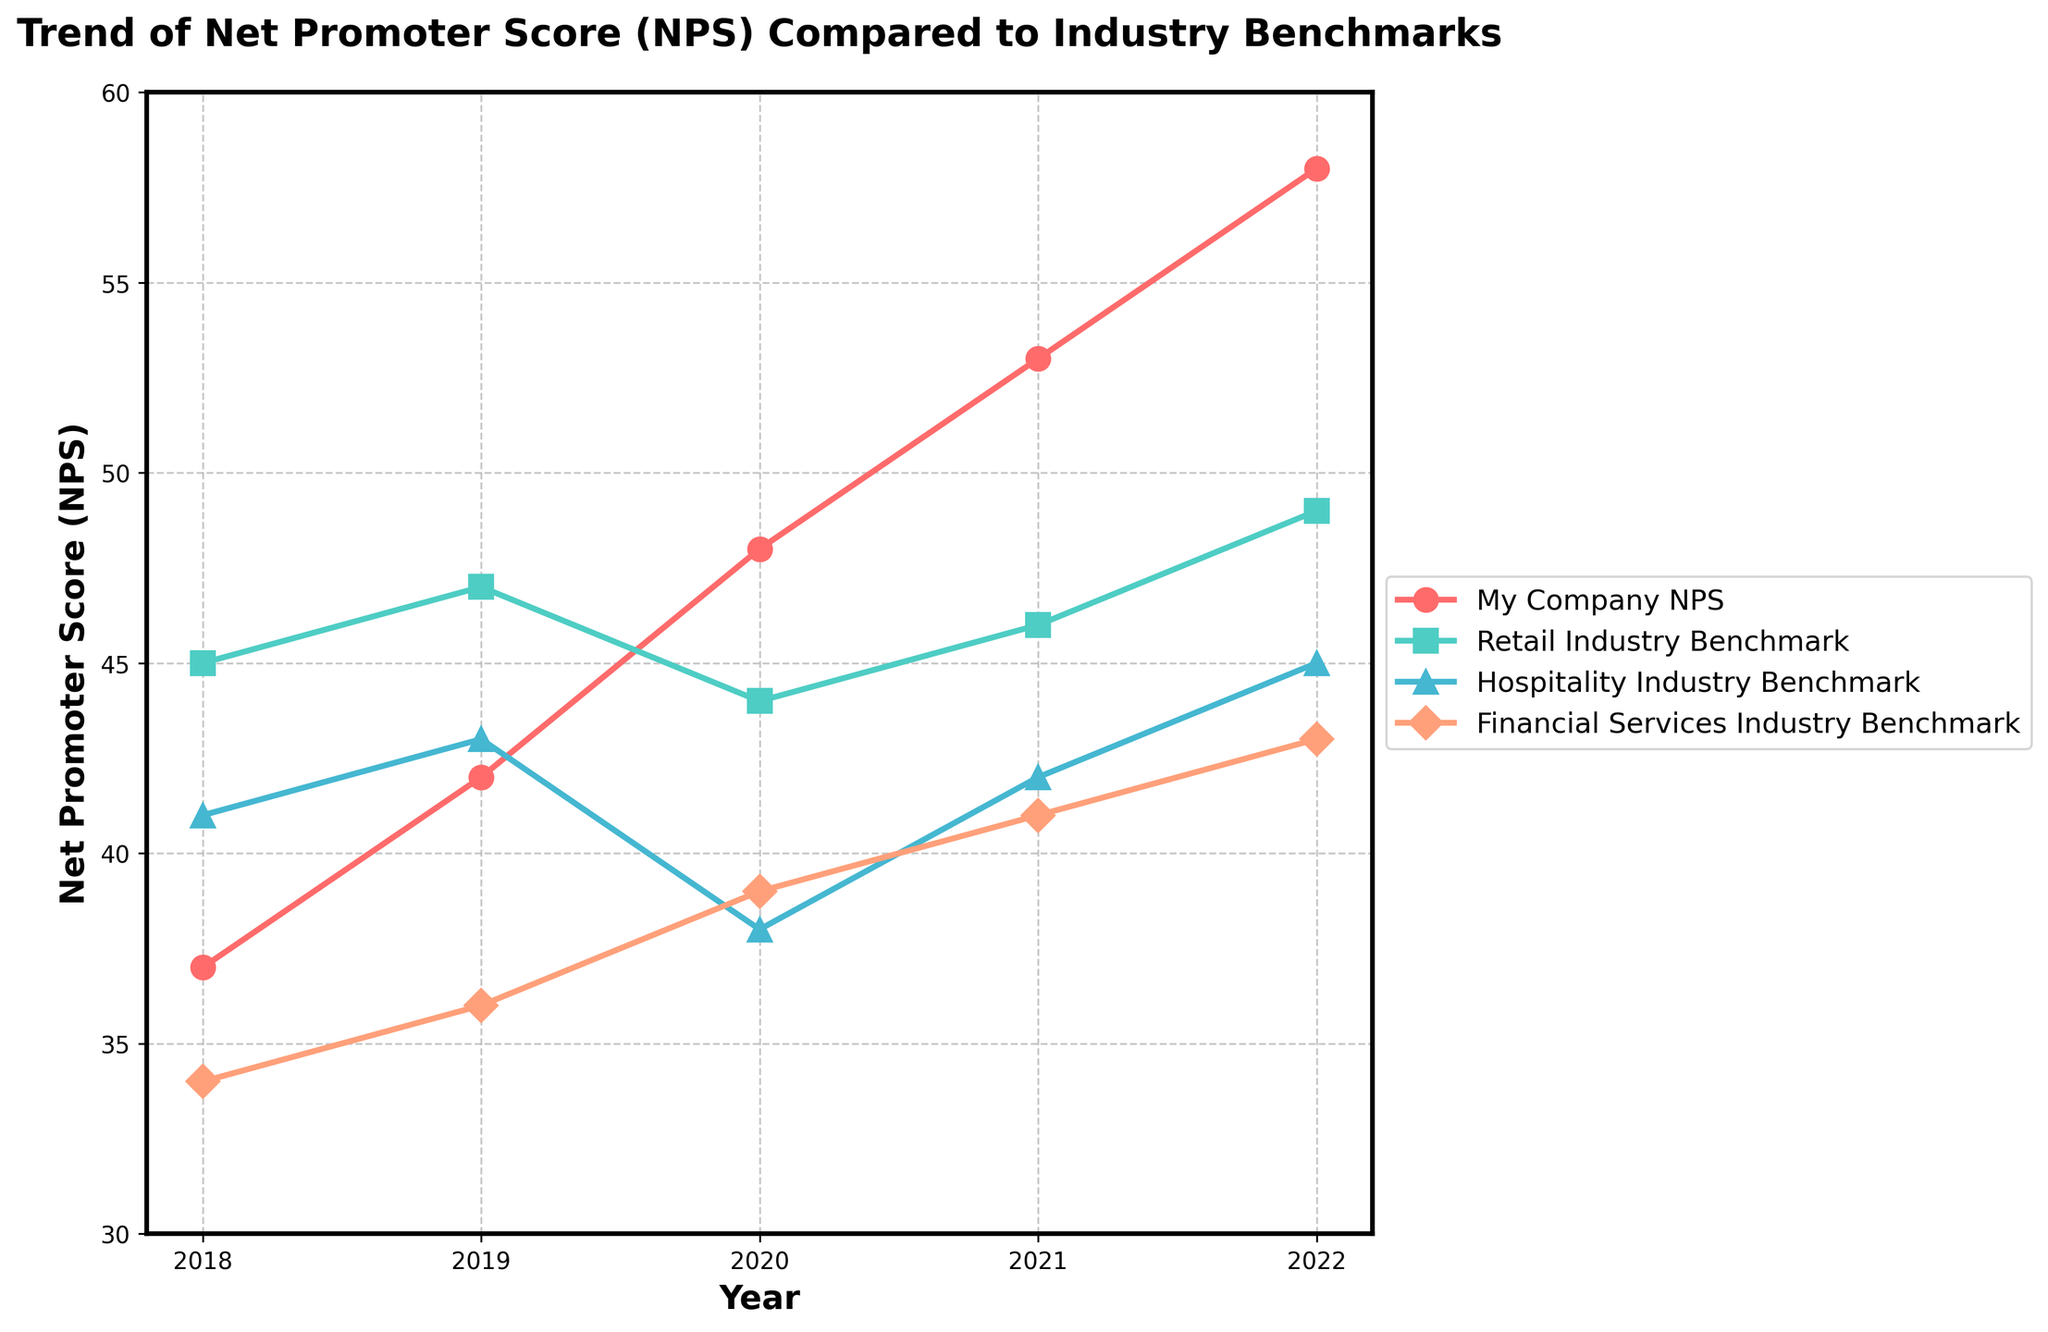What trend does the Net Promoter Score (NPS) for my company show over the past 5 years? The NPS for my company has shown a consistent upward trend from 37 in 2018 to 58 in 2022.
Answer: Consistent upward trend How does my company's NPS compare to the Retail Industry Benchmark in 2022? In 2022, my company's NPS is 58, while the Retail Industry Benchmark is 49. My company's NPS is higher by 9 points.
Answer: Higher by 9 points Which industry benchmark had the lowest NPS in 2020? In 2020, the Hospitality Industry Benchmark had the lowest NPS at 38.
Answer: Hospitality Industry Benchmark By how much did my company's NPS increase from 2018 to 2021? My company's NPS increased from 37 in 2018 to 53 in 2021. The increase is 53 - 37, which is 16 points.
Answer: 16 points Between which years did the Financial Services Industry Benchmark show the greatest increase? The Financial Services Industry Benchmark showed the greatest increase between 2019 and 2020, moving from 36 to 39, an increase of 3 points.
Answer: 2019 to 2020 What is the average NPS for the Hospitality Industry Benchmark over the 5 years? The NPS values for the Hospitality Industry Benchmark are 41 (2018), 43 (2019), 38 (2020), 42 (2021), and 45 (2022). The average is: (41 + 43 + 38 + 42 + 45) / 5 = 41.8
Answer: 41.8 Which industry benchmark has an NPS closest to my company's NPS in 2019, and what is the difference? In 2019, my company's NPS is 42. The Retail Industry Benchmark is 47, Hospitality Industry Benchmark is 43, and Financial Services Industry Benchmark is 36. The Hospitality Industry Benchmark, with 43, is closest, with a difference of 1 point.
Answer: Hospitality Industry Benchmark; 1 point How does the trend of the Retail Industry Benchmark compare to my company's NPS trend over the 5 years? Both the Retail Industry Benchmark and my company's NPS show increasing trends. However, my company's NPS increases more steeply, from 37 to 58, while the Retail Industry Benchmark goes from 45 to 49.
Answer: Both increasing, but my company more steeply What was the difference between the highest and lowest NPS scores in 2021? In 2021, my company had the highest NPS of 53, and the Retail Industry Benchmark had the lowest of 46. The difference is 53 - 46 = 7 points.
Answer: 7 points 